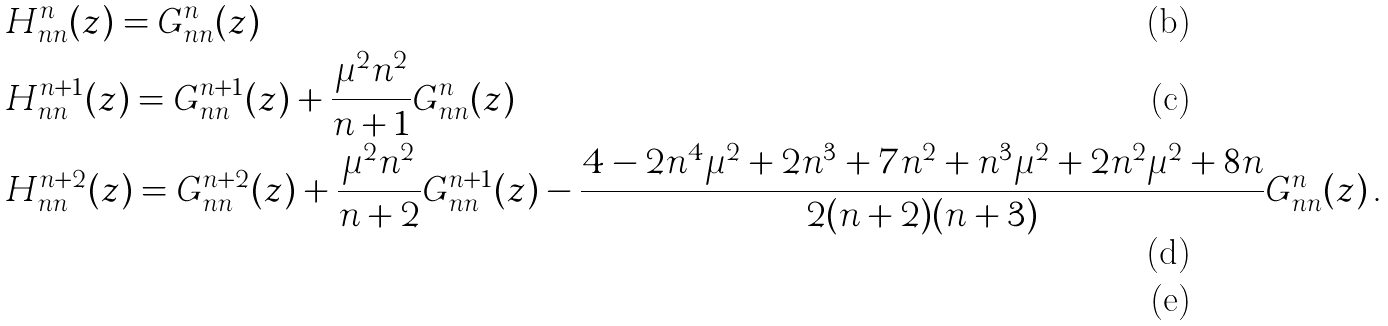<formula> <loc_0><loc_0><loc_500><loc_500>& H ^ { n } _ { n n } ( z ) = G ^ { n } _ { n n } ( z ) \\ & H ^ { n + 1 } _ { n n } ( z ) = G ^ { n + 1 } _ { n n } ( z ) + \frac { \mu ^ { 2 } n ^ { 2 } } { n + 1 } G ^ { n } _ { n n } ( z ) \\ & H ^ { n + 2 } _ { n n } ( z ) = G ^ { n + 2 } _ { n n } ( z ) + \frac { \mu ^ { 2 } n ^ { 2 } } { n + 2 } G ^ { n + 1 } _ { n n } ( z ) - \frac { 4 - 2 n ^ { 4 } \mu ^ { 2 } + 2 n ^ { 3 } + 7 n ^ { 2 } + n ^ { 3 } \mu ^ { 2 } + 2 n ^ { 2 } \mu ^ { 2 } + 8 n } { 2 ( n + 2 ) ( n + 3 ) } G ^ { n } _ { n n } ( z ) \, . \\</formula> 